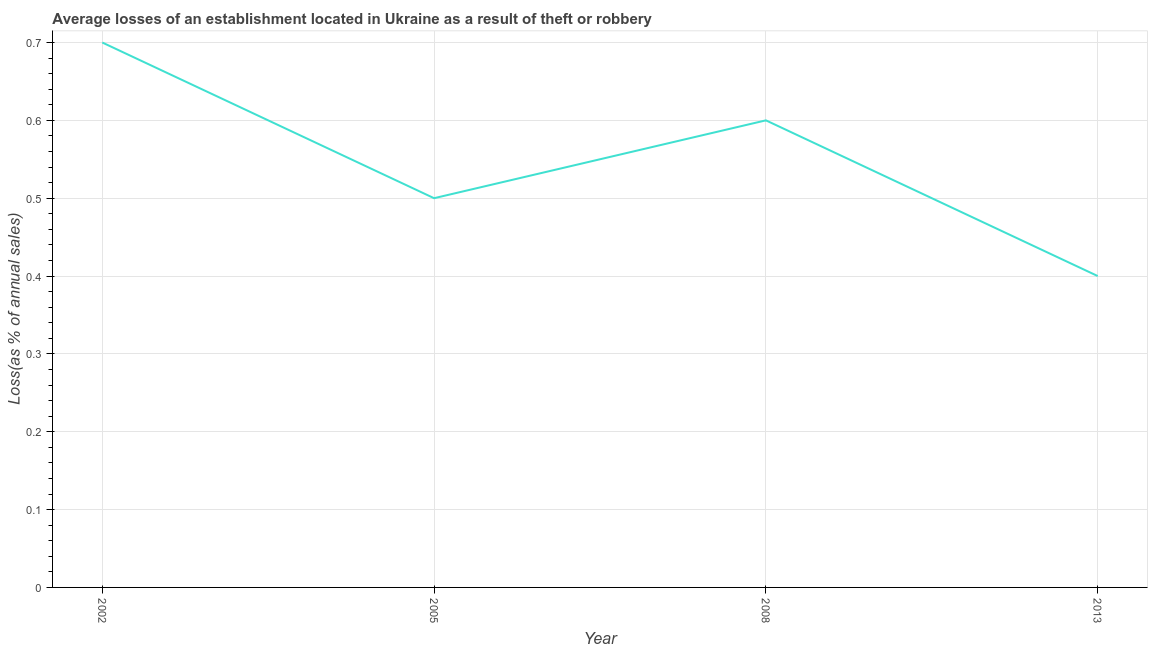What is the losses due to theft in 2002?
Offer a very short reply. 0.7. Across all years, what is the maximum losses due to theft?
Ensure brevity in your answer.  0.7. Across all years, what is the minimum losses due to theft?
Offer a terse response. 0.4. In which year was the losses due to theft maximum?
Offer a terse response. 2002. In which year was the losses due to theft minimum?
Make the answer very short. 2013. What is the sum of the losses due to theft?
Keep it short and to the point. 2.2. What is the difference between the losses due to theft in 2002 and 2008?
Ensure brevity in your answer.  0.1. What is the average losses due to theft per year?
Your answer should be very brief. 0.55. What is the median losses due to theft?
Keep it short and to the point. 0.55. What is the ratio of the losses due to theft in 2002 to that in 2008?
Provide a short and direct response. 1.17. Is the losses due to theft in 2008 less than that in 2013?
Give a very brief answer. No. What is the difference between the highest and the second highest losses due to theft?
Your answer should be very brief. 0.1. Is the sum of the losses due to theft in 2002 and 2005 greater than the maximum losses due to theft across all years?
Your answer should be compact. Yes. What is the difference between the highest and the lowest losses due to theft?
Keep it short and to the point. 0.3. How many lines are there?
Provide a short and direct response. 1. Does the graph contain any zero values?
Provide a short and direct response. No. What is the title of the graph?
Make the answer very short. Average losses of an establishment located in Ukraine as a result of theft or robbery. What is the label or title of the X-axis?
Your response must be concise. Year. What is the label or title of the Y-axis?
Keep it short and to the point. Loss(as % of annual sales). What is the Loss(as % of annual sales) in 2005?
Your answer should be very brief. 0.5. What is the Loss(as % of annual sales) in 2013?
Your answer should be very brief. 0.4. What is the difference between the Loss(as % of annual sales) in 2005 and 2008?
Keep it short and to the point. -0.1. What is the difference between the Loss(as % of annual sales) in 2005 and 2013?
Your answer should be compact. 0.1. What is the ratio of the Loss(as % of annual sales) in 2002 to that in 2005?
Make the answer very short. 1.4. What is the ratio of the Loss(as % of annual sales) in 2002 to that in 2008?
Your answer should be very brief. 1.17. What is the ratio of the Loss(as % of annual sales) in 2005 to that in 2008?
Provide a succinct answer. 0.83. What is the ratio of the Loss(as % of annual sales) in 2008 to that in 2013?
Provide a short and direct response. 1.5. 